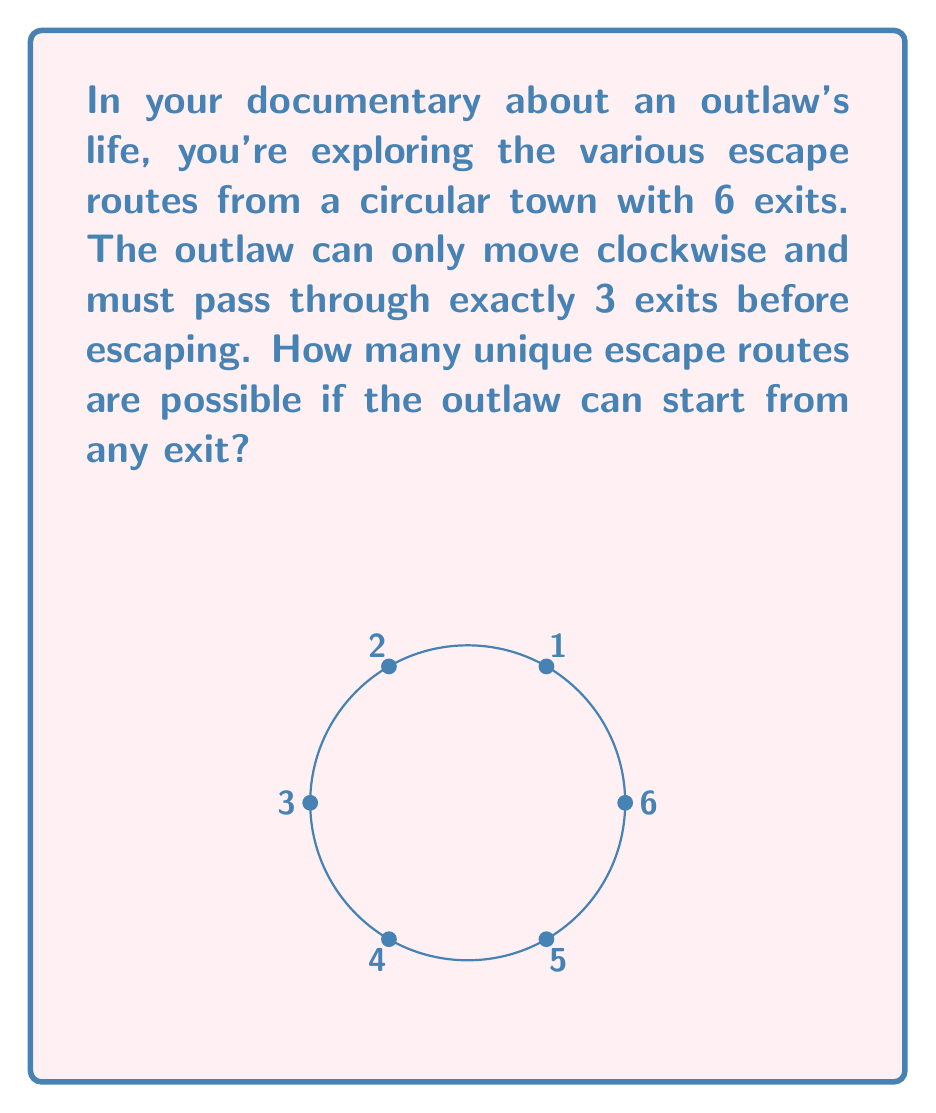Can you answer this question? Let's approach this step-by-step:

1) First, we need to understand that this problem can be modeled using a ring structure. The town is essentially a ring with 6 elements (exits).

2) In ring theory, we're dealing with a cyclic group of order 6, denoted as $\mathbb{Z}_6$.

3) The outlaw's movement can be represented as a sequence of 3 numbers in $\mathbb{Z}_6$, where each number represents an exit.

4) Since the outlaw moves clockwise and must pass through 3 exits, we're looking for sequences of the form $(a, a+1, a+2)$ in $\mathbb{Z}_6$, where $a$ is the starting point.

5) Due to the cyclic nature of the ring, we need to consider that $5+1 \equiv 0 \pmod{6}$ and $5+2 \equiv 1 \pmod{6}$.

6) Let's list all possible sequences:
   $(0, 1, 2)$, $(1, 2, 3)$, $(2, 3, 4)$, $(3, 4, 5)$, $(4, 5, 0)$, $(5, 0, 1)$

7) We can see that there are 6 unique sequences, one starting from each exit.

Therefore, there are 6 possible unique escape routes.
Answer: 6 escape routes 